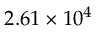Convert formula to latex. <formula><loc_0><loc_0><loc_500><loc_500>2 . 6 1 \times 1 0 ^ { 4 }</formula> 